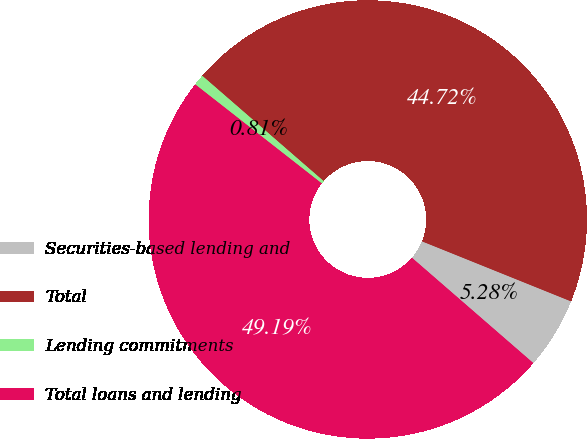<chart> <loc_0><loc_0><loc_500><loc_500><pie_chart><fcel>Securities-based lending and<fcel>Total<fcel>Lending commitments<fcel>Total loans and lending<nl><fcel>5.28%<fcel>44.72%<fcel>0.81%<fcel>49.19%<nl></chart> 